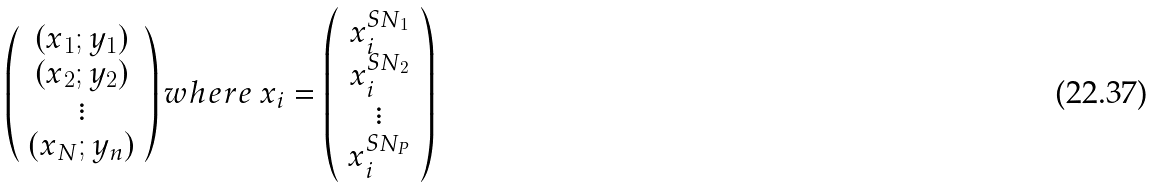Convert formula to latex. <formula><loc_0><loc_0><loc_500><loc_500>\left ( \begin{array} { c } ( x _ { 1 } ; y _ { 1 } ) \\ ( x _ { 2 } ; y _ { 2 } ) \\ \vdots \\ ( x _ { N } ; y _ { n } ) \end{array} \right ) w h e r e \, x _ { i } = \left ( \begin{array} { c } x _ { i } ^ { S N _ { 1 } } \\ x _ { i } ^ { S N _ { 2 } } \\ \vdots \\ x _ { i } ^ { S N _ { P } } \\ \end{array} \right )</formula> 